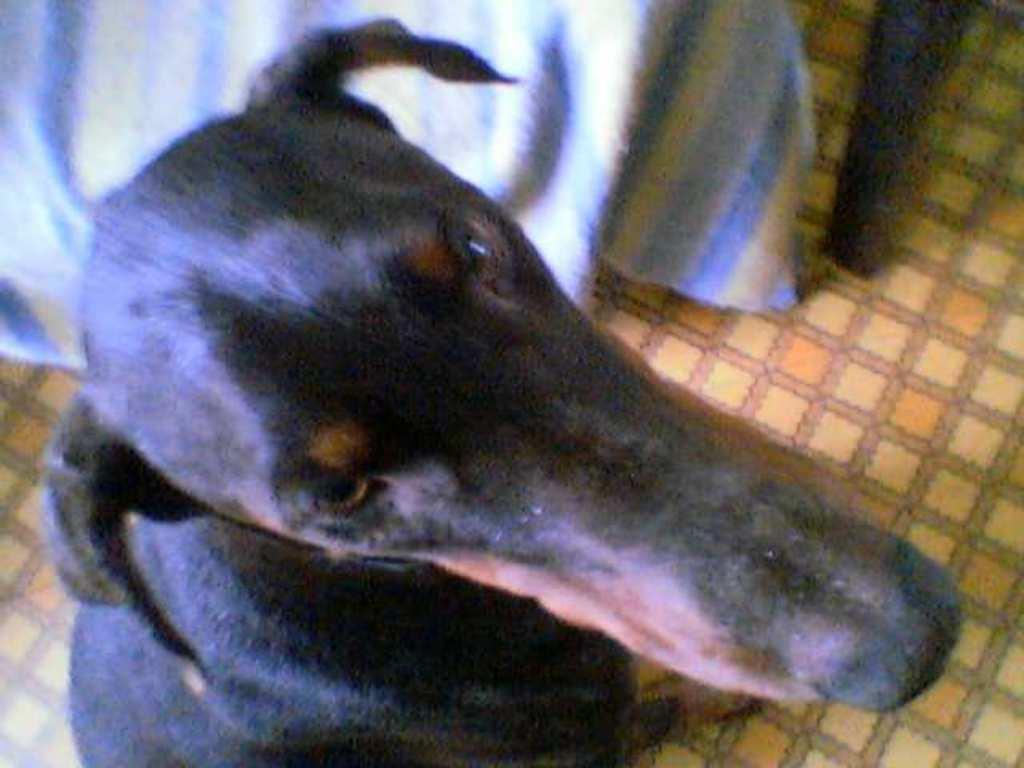How would you summarize this image in a sentence or two? In the center of the image we can see one dog on the floor. And the dog is in a black and brown color. At the top of the image, we can see one cloth and one wooden object. 